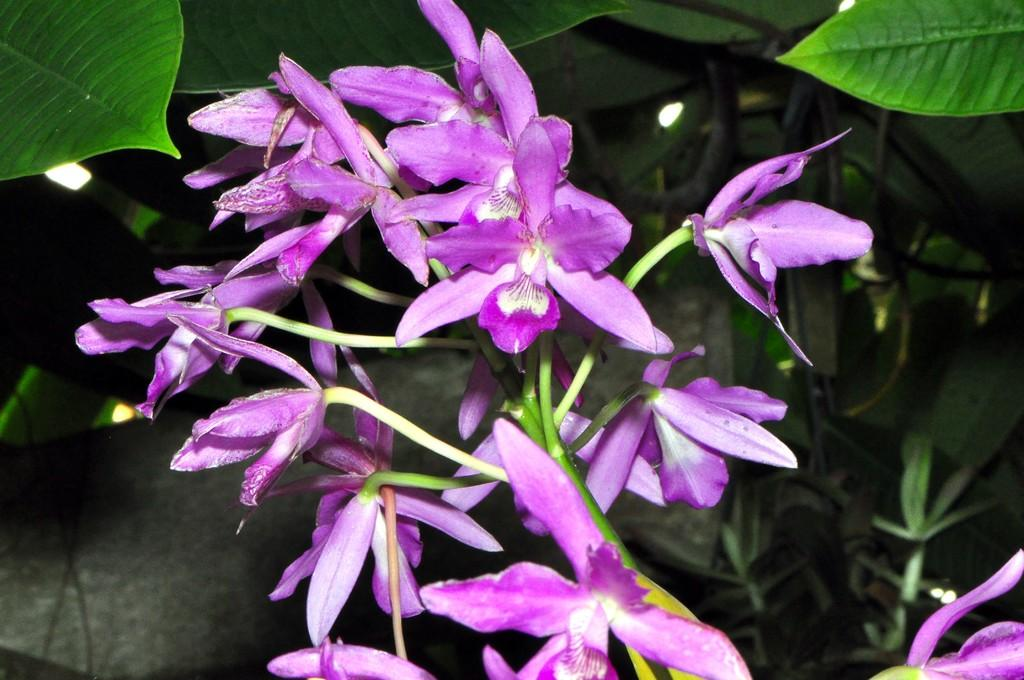What type of flowers can be seen in the image? There are purple color flowers in the image. What is the color of the plants on which the flowers are growing? The plants are green. What type of grain is visible in the image? There is no grain visible in the image; it features purple color flowers on green plants. Are there any books present in the image? There are no books present in the image. 